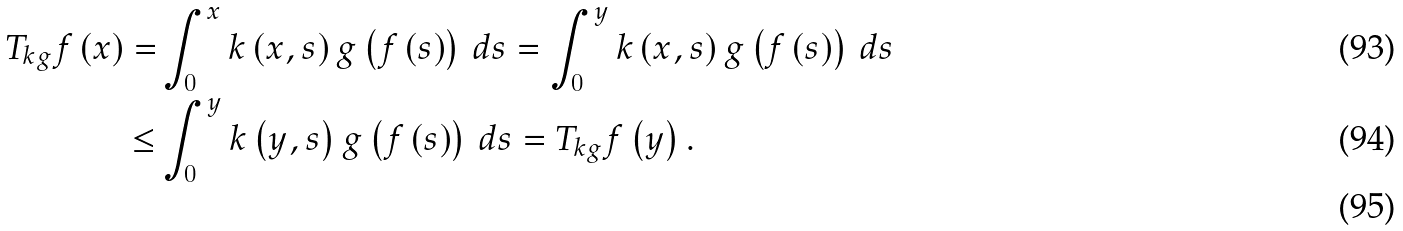<formula> <loc_0><loc_0><loc_500><loc_500>T _ { k g } f \left ( x \right ) = & \int _ { 0 } ^ { x } k \left ( x , s \right ) g \left ( f \left ( s \right ) \right ) \, d s = \int _ { 0 } ^ { y } k \left ( x , s \right ) g \left ( f \left ( s \right ) \right ) \, d s \\ \leq & \int _ { 0 } ^ { y } k \left ( y , s \right ) g \left ( f \left ( s \right ) \right ) \, d s = T _ { k g } f \left ( y \right ) . \\</formula> 